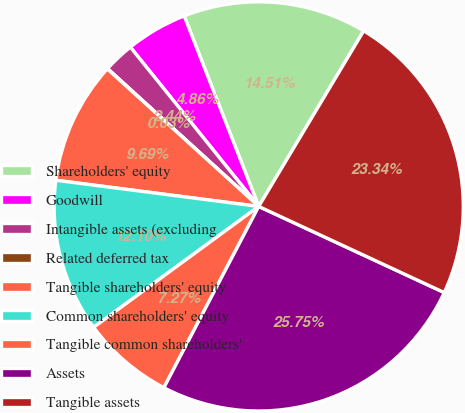Convert chart to OTSL. <chart><loc_0><loc_0><loc_500><loc_500><pie_chart><fcel>Shareholders' equity<fcel>Goodwill<fcel>Intangible assets (excluding<fcel>Related deferred tax<fcel>Tangible shareholders' equity<fcel>Common shareholders' equity<fcel>Tangible common shareholders'<fcel>Assets<fcel>Tangible assets<nl><fcel>14.51%<fcel>4.86%<fcel>2.44%<fcel>0.03%<fcel>9.69%<fcel>12.1%<fcel>7.27%<fcel>25.75%<fcel>23.34%<nl></chart> 